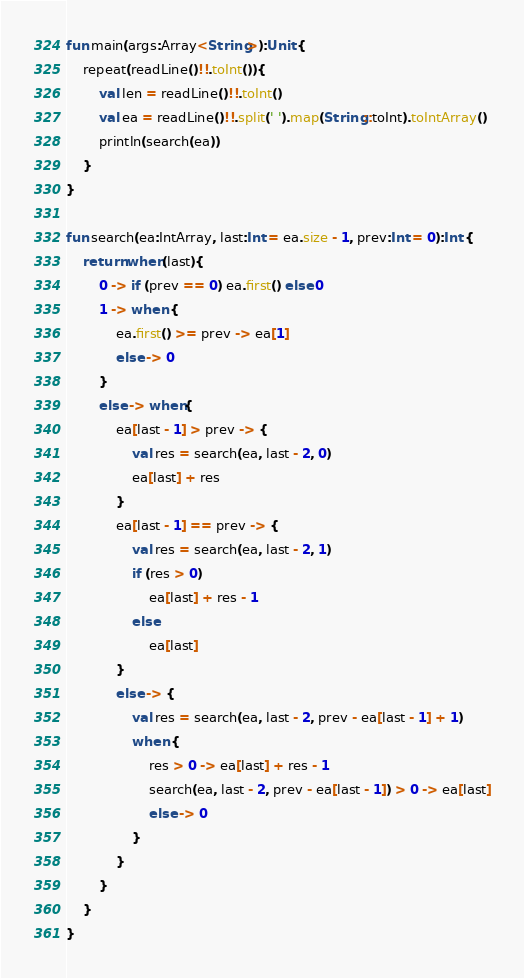<code> <loc_0><loc_0><loc_500><loc_500><_Kotlin_>fun main(args:Array<String>):Unit {
    repeat(readLine()!!.toInt()){
        val len = readLine()!!.toInt()
        val ea = readLine()!!.split(' ').map(String::toInt).toIntArray()
        println(search(ea))
    }
}

fun search(ea:IntArray, last:Int = ea.size - 1, prev:Int = 0):Int {
    return when(last){
        0 -> if (prev == 0) ea.first() else 0
        1 -> when {
            ea.first() >= prev -> ea[1]
            else -> 0
        }
        else -> when{
            ea[last - 1] > prev -> {
                val res = search(ea, last - 2, 0)
                ea[last] + res
            }
            ea[last - 1] == prev -> {
                val res = search(ea, last - 2, 1)
                if (res > 0)
                    ea[last] + res - 1
                else
                    ea[last]
            }
            else -> {
                val res = search(ea, last - 2, prev - ea[last - 1] + 1)
                when {
                    res > 0 -> ea[last] + res - 1
                    search(ea, last - 2, prev - ea[last - 1]) > 0 -> ea[last]
                    else -> 0
                }
            }
        }
    }
}
</code> 